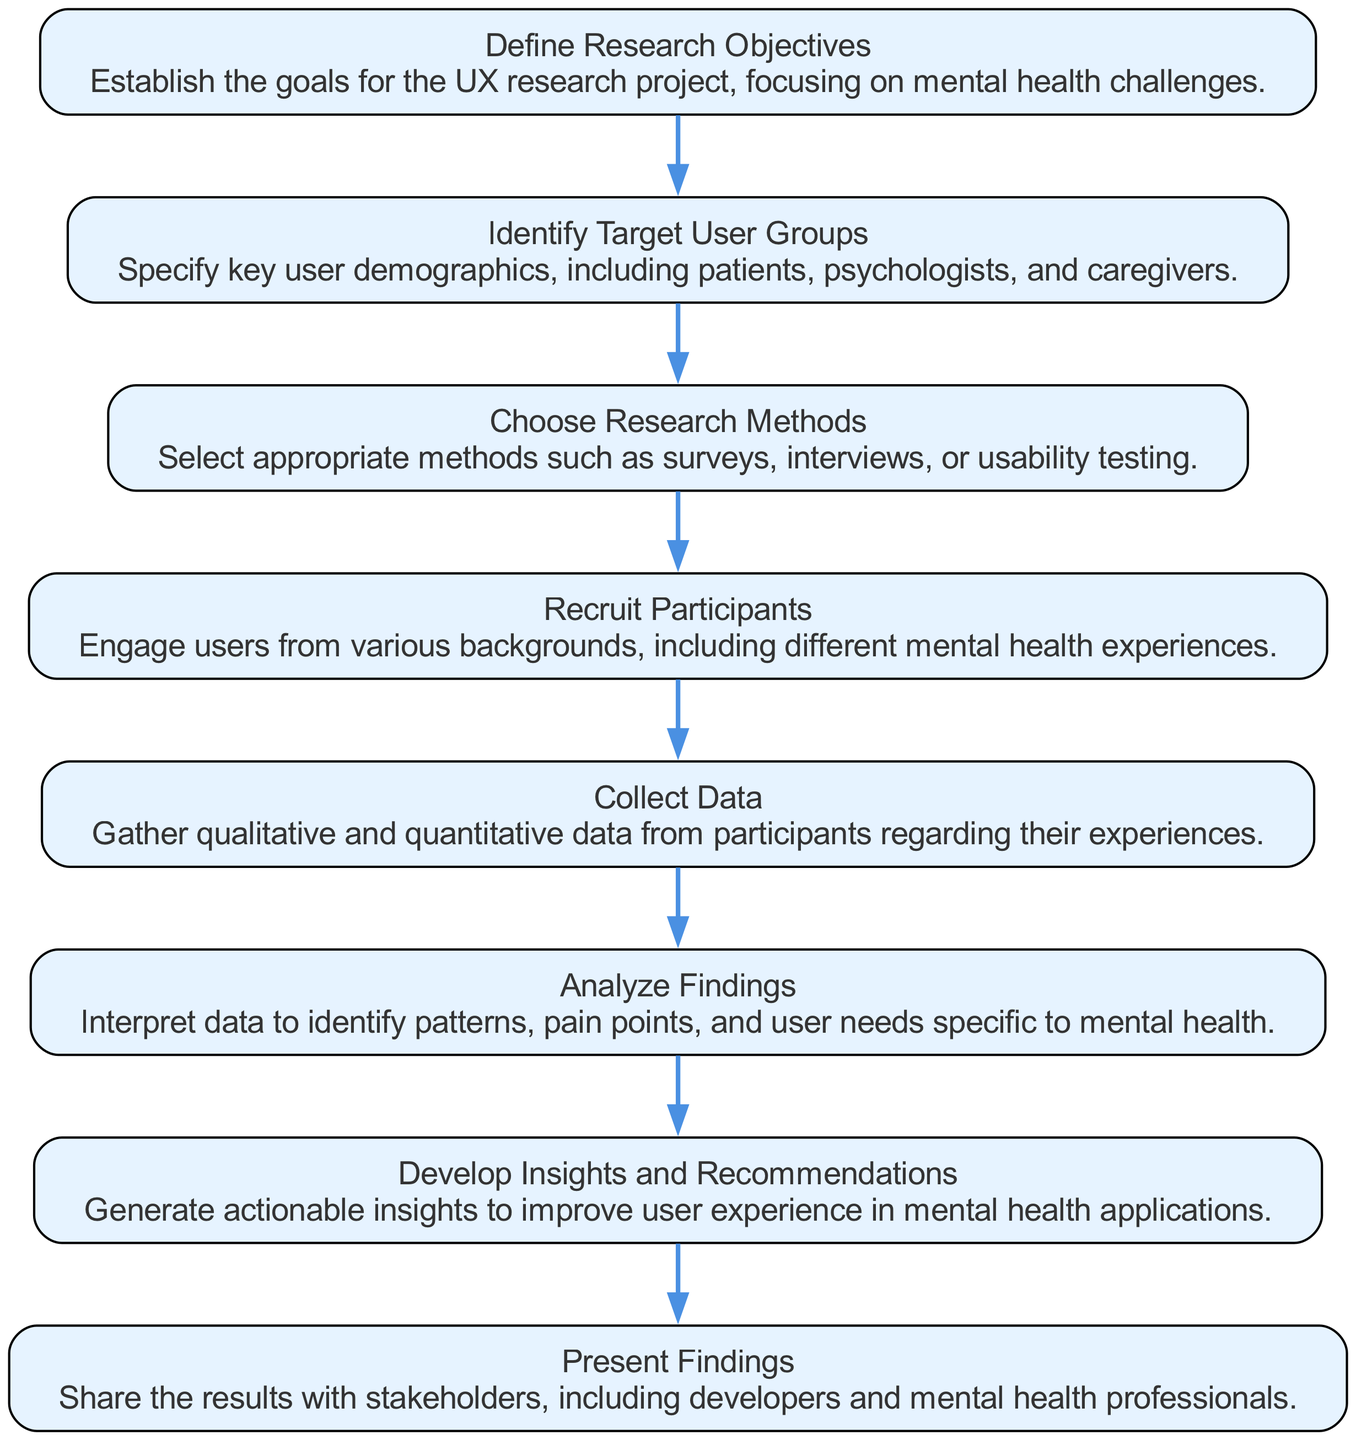What is the first step in the UX research project? The first step in the UX research project is "Define Research Objectives," which establishes the goals for the project related to mental health challenges.
Answer: Define Research Objectives How many steps are there in total in this flow chart? By counting the steps listed in the flow chart, we find that there are 8 distinct steps presented in the diagram.
Answer: 8 Which step follows "Collect Data"? The step that follows "Collect Data" is "Analyze Findings." This indicates a progression where data collection leads to the analysis of that data.
Answer: Analyze Findings What is the main focus of the second step? The second step, "Identify Target User Groups," focuses on specifying key user demographics such as patients, psychologists, and caregivers essential for the research.
Answer: Specify key user demographics What key action is involved in the step before "Develop Insights and Recommendations"? The step before "Develop Insights and Recommendations" is "Analyze Findings," and the key action involved in this step is interpreting the data to identify patterns, pain points, and user needs.
Answer: Analyze Findings What is the relationship between "Recruit Participants" and "Collect Data"? "Recruit Participants" is a prerequisite to "Collect Data," meaning you must engage users before you can gather data about their experiences.
Answer: Prerequisite relationship Which step involves sharing the results with stakeholders? The step that involves sharing results with stakeholders is "Present Findings," which indicates communication of research outcomes to relevant parties.
Answer: Present Findings What type of data is gathered in the "Collect Data" step? The "Collect Data" step involves gathering both qualitative and quantitative data from participants regarding their experiences.
Answer: Qualitative and quantitative data 